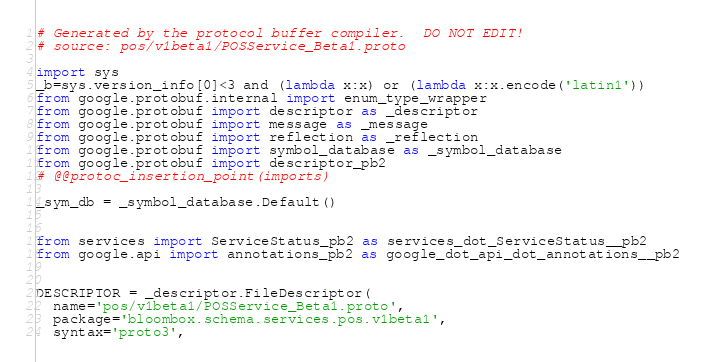Convert code to text. <code><loc_0><loc_0><loc_500><loc_500><_Python_># Generated by the protocol buffer compiler.  DO NOT EDIT!
# source: pos/v1beta1/POSService_Beta1.proto

import sys
_b=sys.version_info[0]<3 and (lambda x:x) or (lambda x:x.encode('latin1'))
from google.protobuf.internal import enum_type_wrapper
from google.protobuf import descriptor as _descriptor
from google.protobuf import message as _message
from google.protobuf import reflection as _reflection
from google.protobuf import symbol_database as _symbol_database
from google.protobuf import descriptor_pb2
# @@protoc_insertion_point(imports)

_sym_db = _symbol_database.Default()


from services import ServiceStatus_pb2 as services_dot_ServiceStatus__pb2
from google.api import annotations_pb2 as google_dot_api_dot_annotations__pb2


DESCRIPTOR = _descriptor.FileDescriptor(
  name='pos/v1beta1/POSService_Beta1.proto',
  package='bloombox.schema.services.pos.v1beta1',
  syntax='proto3',</code> 